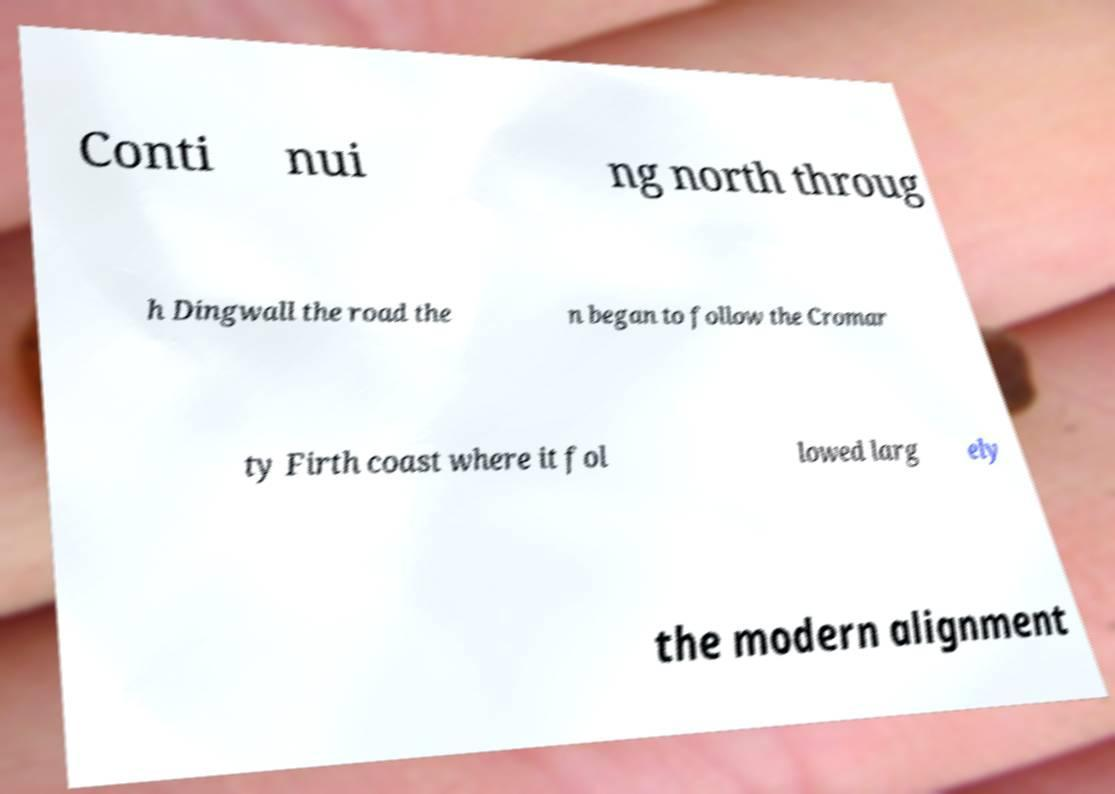Please identify and transcribe the text found in this image. Conti nui ng north throug h Dingwall the road the n began to follow the Cromar ty Firth coast where it fol lowed larg ely the modern alignment 